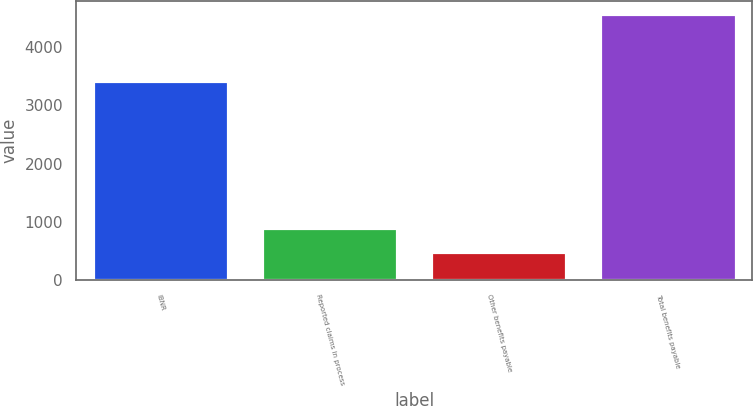<chart> <loc_0><loc_0><loc_500><loc_500><bar_chart><fcel>IBNR<fcel>Reported claims in process<fcel>Other benefits payable<fcel>Total benefits payable<nl><fcel>3422<fcel>894.6<fcel>487<fcel>4563<nl></chart> 